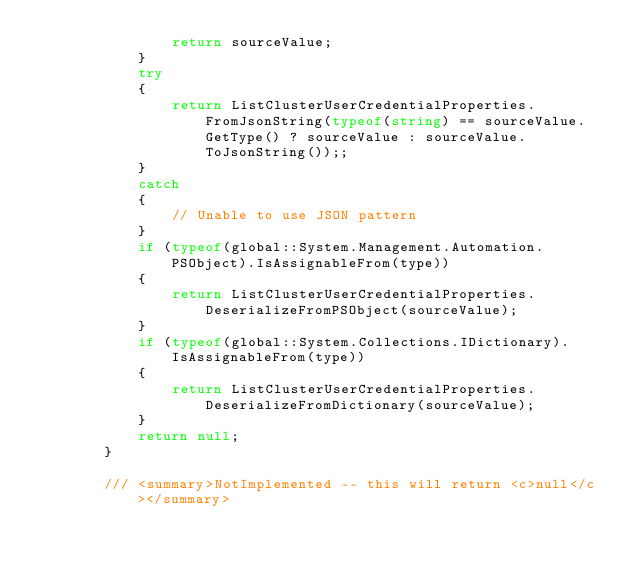<code> <loc_0><loc_0><loc_500><loc_500><_C#_>                return sourceValue;
            }
            try
            {
                return ListClusterUserCredentialProperties.FromJsonString(typeof(string) == sourceValue.GetType() ? sourceValue : sourceValue.ToJsonString());;
            }
            catch
            {
                // Unable to use JSON pattern
            }
            if (typeof(global::System.Management.Automation.PSObject).IsAssignableFrom(type))
            {
                return ListClusterUserCredentialProperties.DeserializeFromPSObject(sourceValue);
            }
            if (typeof(global::System.Collections.IDictionary).IsAssignableFrom(type))
            {
                return ListClusterUserCredentialProperties.DeserializeFromDictionary(sourceValue);
            }
            return null;
        }

        /// <summary>NotImplemented -- this will return <c>null</c></summary></code> 